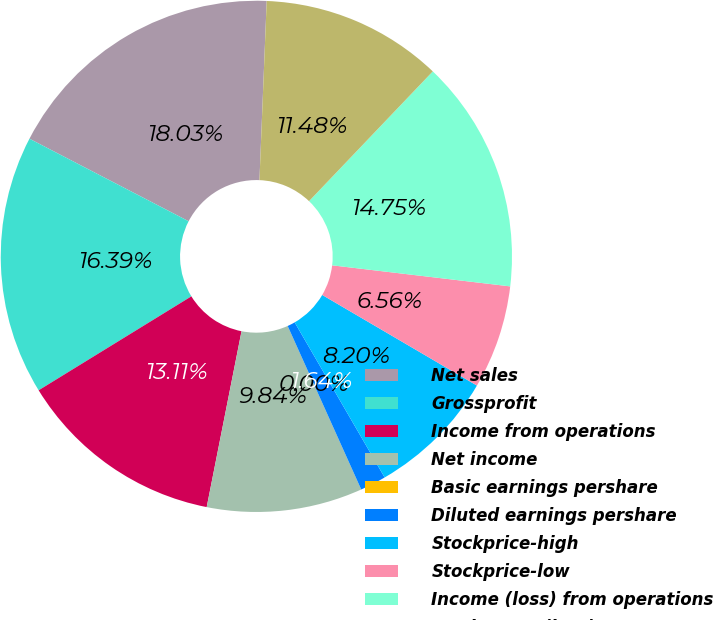Convert chart to OTSL. <chart><loc_0><loc_0><loc_500><loc_500><pie_chart><fcel>Net sales<fcel>Grossprofit<fcel>Income from operations<fcel>Net income<fcel>Basic earnings pershare<fcel>Diluted earnings pershare<fcel>Stockprice-high<fcel>Stockprice-low<fcel>Income (loss) from operations<fcel>Net income (loss)<nl><fcel>18.03%<fcel>16.39%<fcel>13.11%<fcel>9.84%<fcel>0.0%<fcel>1.64%<fcel>8.2%<fcel>6.56%<fcel>14.75%<fcel>11.48%<nl></chart> 